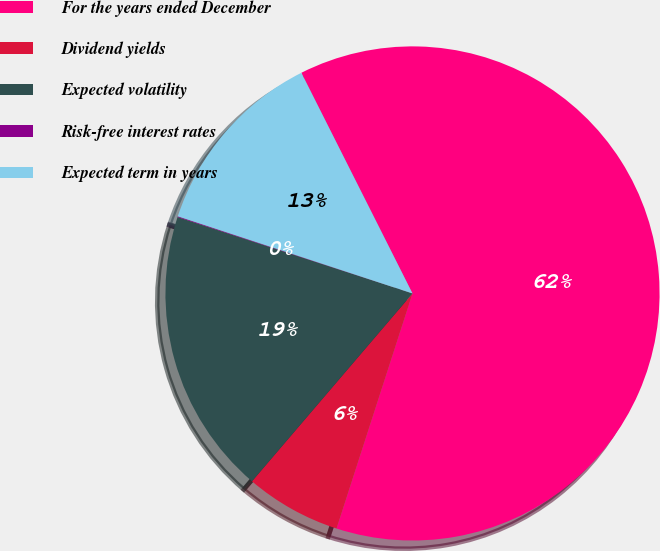Convert chart. <chart><loc_0><loc_0><loc_500><loc_500><pie_chart><fcel>For the years ended December<fcel>Dividend yields<fcel>Expected volatility<fcel>Risk-free interest rates<fcel>Expected term in years<nl><fcel>62.4%<fcel>6.28%<fcel>18.75%<fcel>0.05%<fcel>12.52%<nl></chart> 